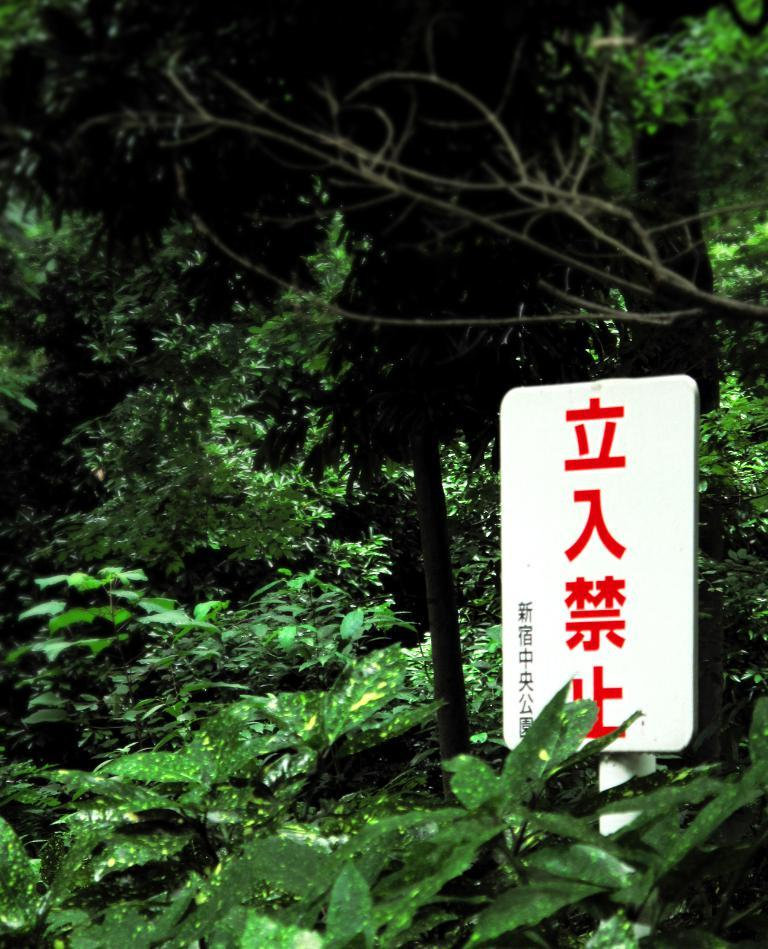Where was the image taken? The image was taken outdoors. What can be seen in the background of the image? There are many trees in the image. What type of vegetation is present in the image? There are plants with green leaves in the image. What is on the right side of the image? There is a board with text on the right side of the image. What type of oven is visible in the image? There is no oven present in the image. What design elements can be seen in the plants with green leaves? The plants with green leaves do not have any design elements; they are natural vegetation. 